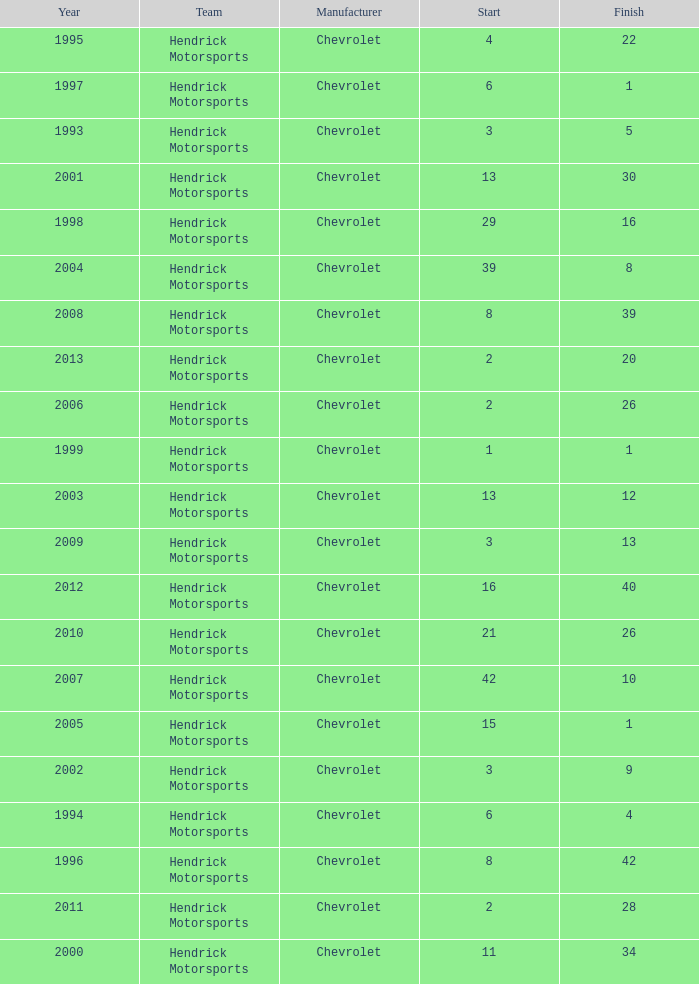Help me parse the entirety of this table. {'header': ['Year', 'Team', 'Manufacturer', 'Start', 'Finish'], 'rows': [['1995', 'Hendrick Motorsports', 'Chevrolet', '4', '22'], ['1997', 'Hendrick Motorsports', 'Chevrolet', '6', '1'], ['1993', 'Hendrick Motorsports', 'Chevrolet', '3', '5'], ['2001', 'Hendrick Motorsports', 'Chevrolet', '13', '30'], ['1998', 'Hendrick Motorsports', 'Chevrolet', '29', '16'], ['2004', 'Hendrick Motorsports', 'Chevrolet', '39', '8'], ['2008', 'Hendrick Motorsports', 'Chevrolet', '8', '39'], ['2013', 'Hendrick Motorsports', 'Chevrolet', '2', '20'], ['2006', 'Hendrick Motorsports', 'Chevrolet', '2', '26'], ['1999', 'Hendrick Motorsports', 'Chevrolet', '1', '1'], ['2003', 'Hendrick Motorsports', 'Chevrolet', '13', '12'], ['2009', 'Hendrick Motorsports', 'Chevrolet', '3', '13'], ['2012', 'Hendrick Motorsports', 'Chevrolet', '16', '40'], ['2010', 'Hendrick Motorsports', 'Chevrolet', '21', '26'], ['2007', 'Hendrick Motorsports', 'Chevrolet', '42', '10'], ['2005', 'Hendrick Motorsports', 'Chevrolet', '15', '1'], ['2002', 'Hendrick Motorsports', 'Chevrolet', '3', '9'], ['1994', 'Hendrick Motorsports', 'Chevrolet', '6', '4'], ['1996', 'Hendrick Motorsports', 'Chevrolet', '8', '42'], ['2011', 'Hendrick Motorsports', 'Chevrolet', '2', '28'], ['2000', 'Hendrick Motorsports', 'Chevrolet', '11', '34']]} What was Jeff's finish in 2011? 28.0. 